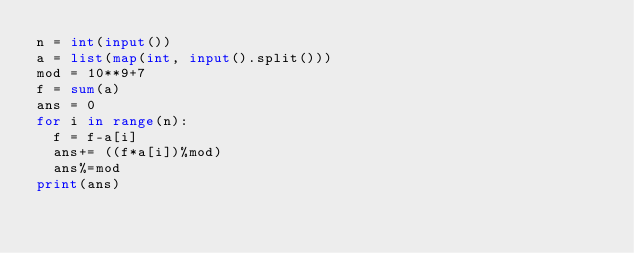<code> <loc_0><loc_0><loc_500><loc_500><_Python_>n = int(input())
a = list(map(int, input().split()))
mod = 10**9+7
f = sum(a)
ans = 0
for i in range(n):
  f = f-a[i]
  ans+= ((f*a[i])%mod)
  ans%=mod
print(ans)</code> 